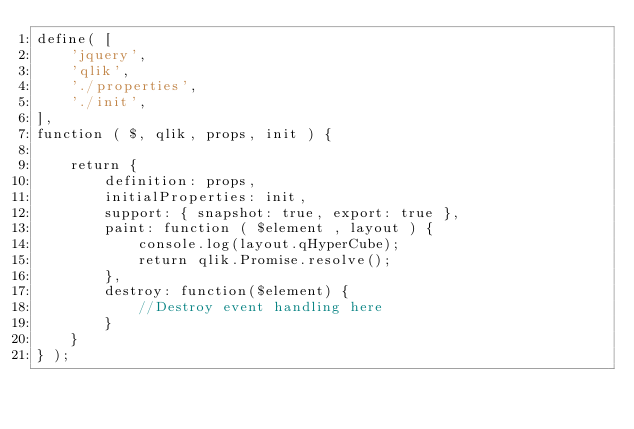Convert code to text. <code><loc_0><loc_0><loc_500><loc_500><_JavaScript_>define( [ 
	'jquery',
	'qlik',
    './properties',
    './init',
],
function ( $, qlik, props, init ) {

	return {
        definition: props,
        initialProperties: init,
        support: { snapshot: true, export: true },
        paint: function ( $element , layout ) {
        	console.log(layout.qHyperCube);
    		return qlik.Promise.resolve();
        },
        destroy: function($element) {
        	//Destroy event handling here
        }
    }
} );

</code> 